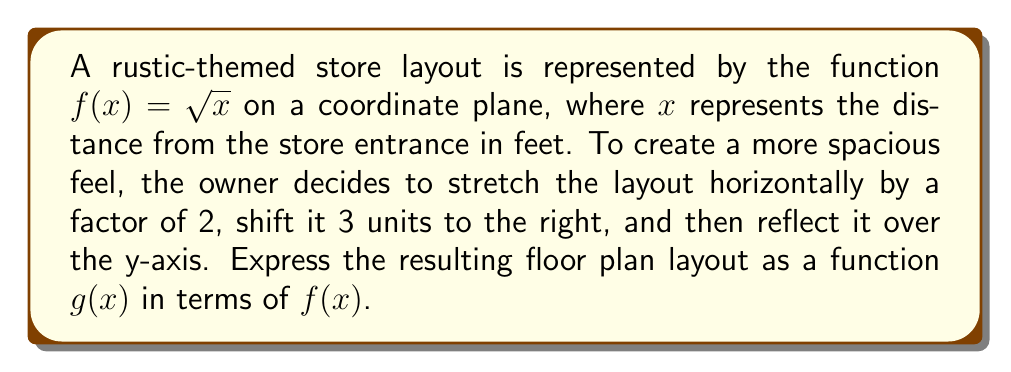Can you solve this math problem? Let's apply the transformations step by step:

1. Stretch horizontally by a factor of 2:
   $f_1(x) = f(\frac{x}{2}) = \sqrt{\frac{x}{2}}$

2. Shift 3 units to the right:
   $f_2(x) = f_1(x-3) = \sqrt{\frac{x-3}{2}}$

3. Reflect over the y-axis:
   To reflect over the y-axis, we replace $x$ with $-x$:
   $g(x) = f_2(-x) = \sqrt{\frac{-x-3}{2}}$

Now, we can simplify this expression:
$$g(x) = \sqrt{\frac{-x-3}{2}} = \sqrt{-\frac{x+3}{2}}$$

To express $g(x)$ in terms of $f(x)$, we need to manipulate the argument:
$$g(x) = \sqrt{-\frac{x+3}{2}} = \sqrt{-(\frac{x+3}{2})} = i\sqrt{\frac{x+3}{2}}$$

Since $f(x) = \sqrt{x}$, we can express $g(x)$ as:
$$g(x) = if(-\frac{x+3}{2})$$
Answer: $g(x) = if(-\frac{x+3}{2})$ 